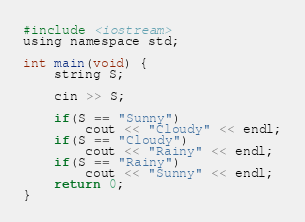<code> <loc_0><loc_0><loc_500><loc_500><_C_>#include <iostream>
using namespace std;

int main(void) {
    string S;

    cin >> S;

    if(S == "Sunny")
        cout << "Cloudy" << endl;
    if(S == "Cloudy")
        cout << "Rainy" << endl;
    if(S == "Rainy")
        cout << "Sunny" << endl;
    return 0;
}</code> 